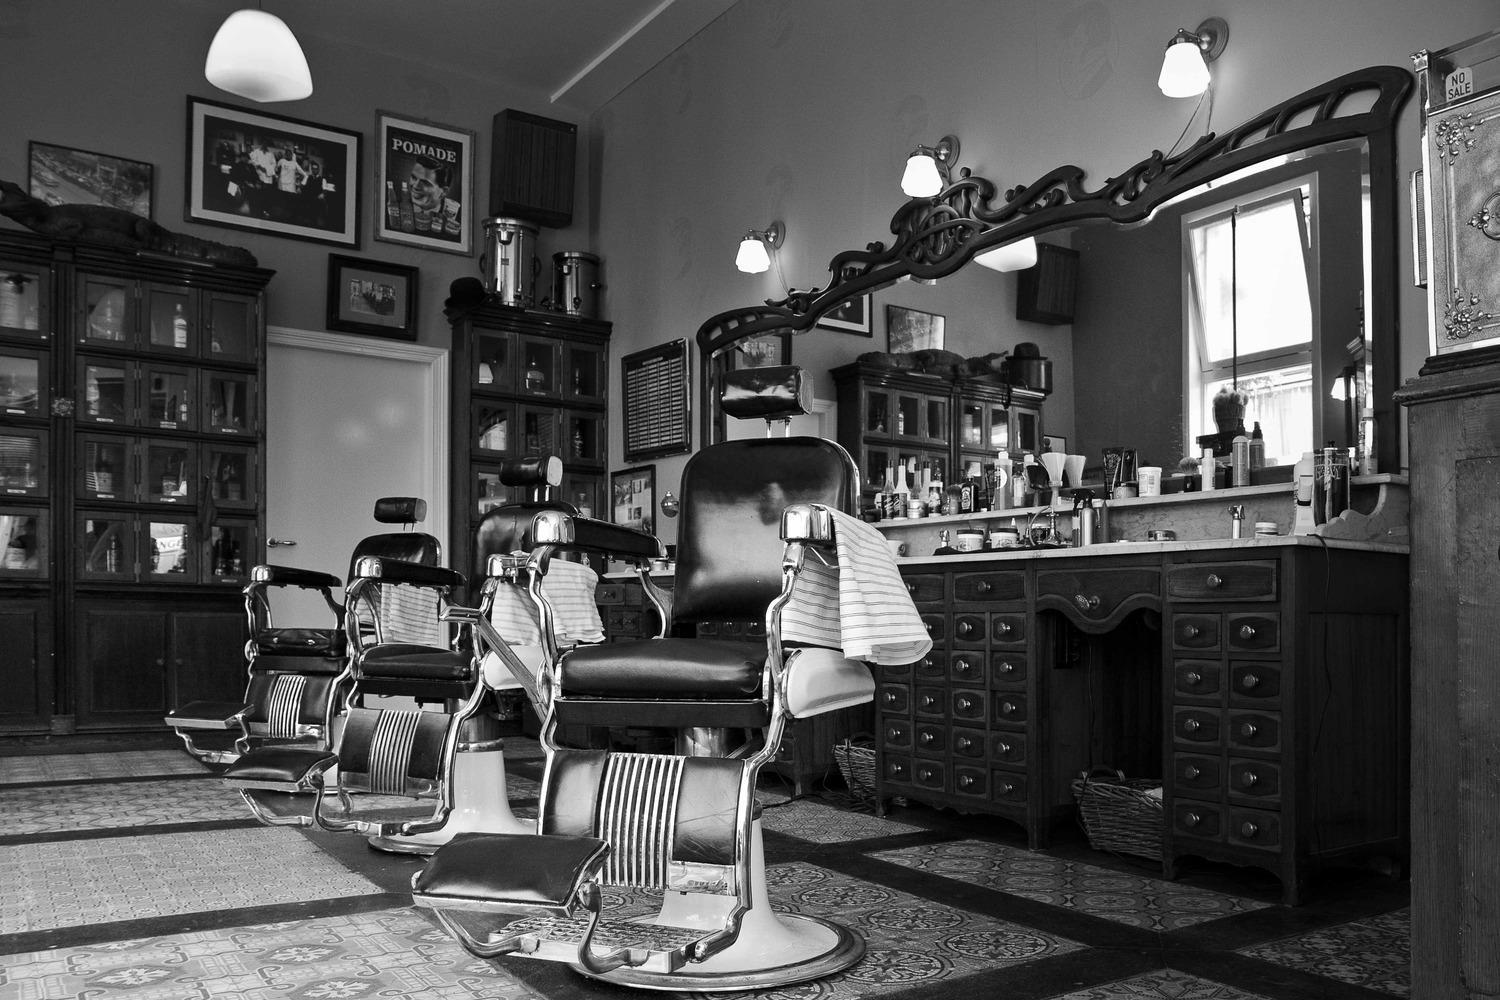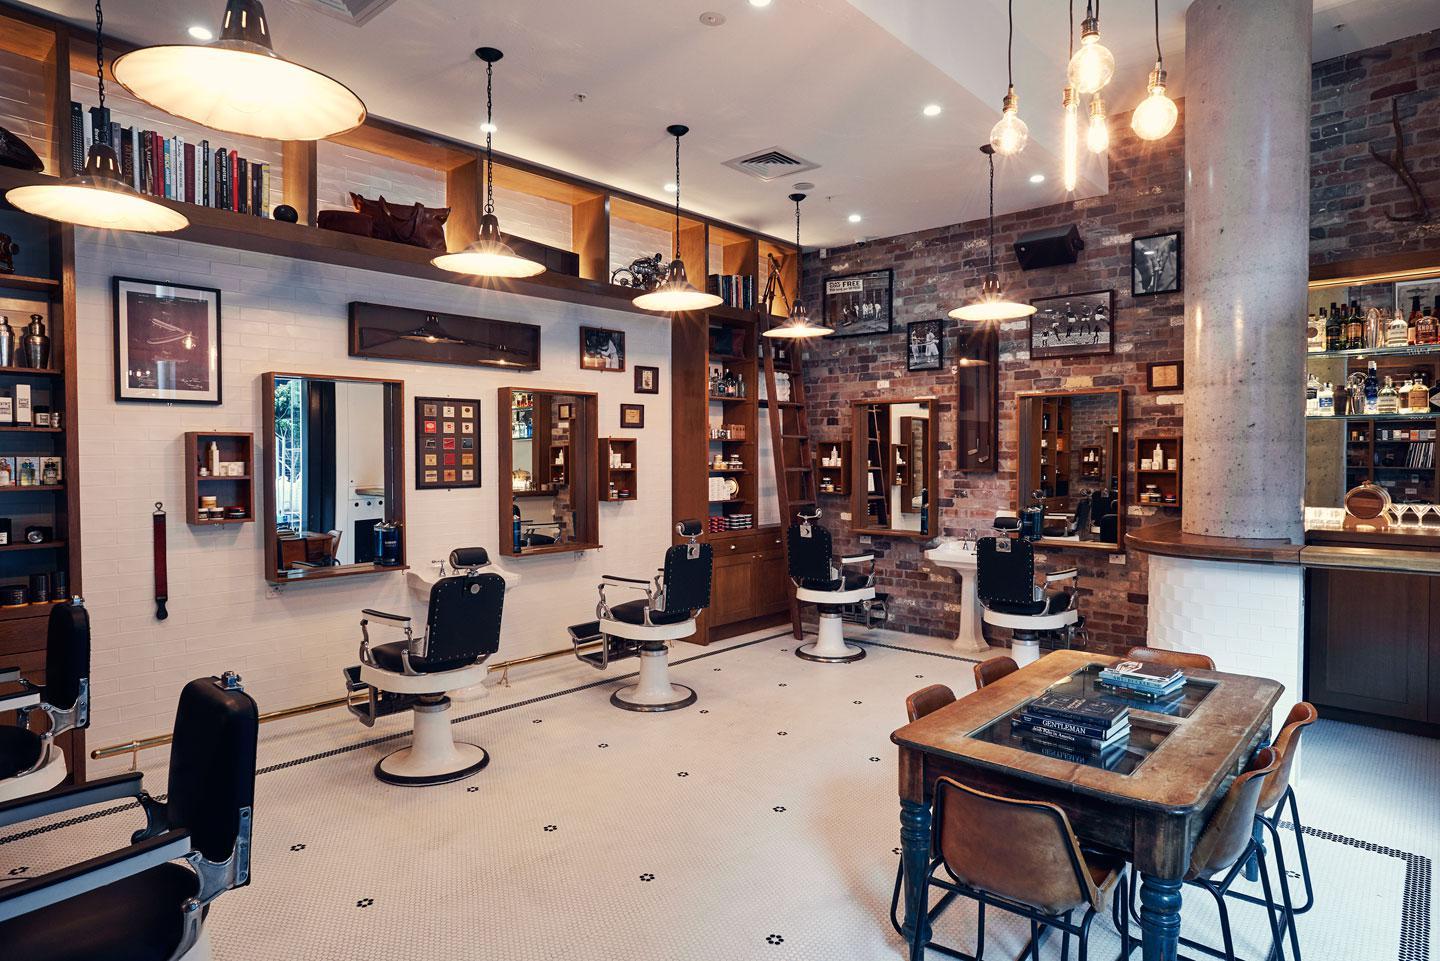The first image is the image on the left, the second image is the image on the right. For the images shown, is this caption "There is at least one person at a barber shop." true? Answer yes or no. No. 